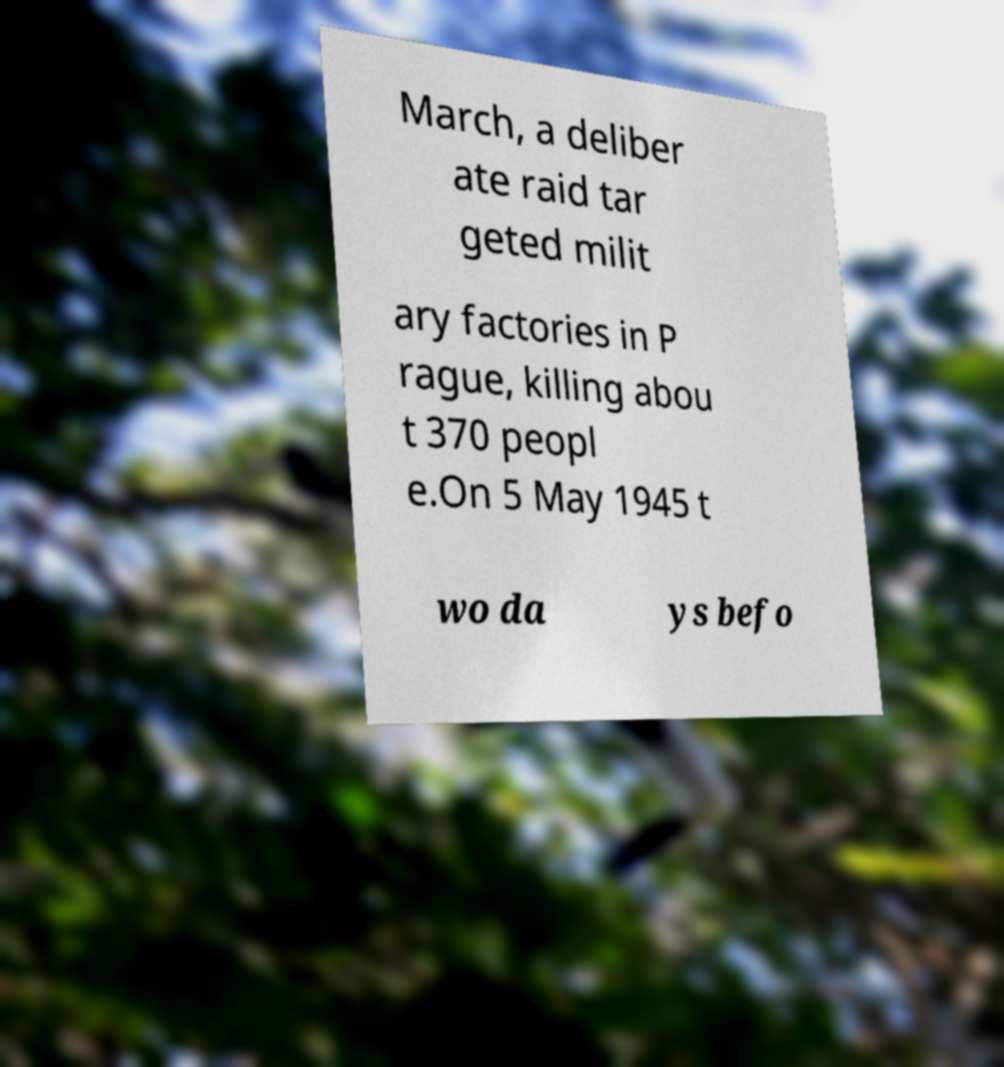Please identify and transcribe the text found in this image. March, a deliber ate raid tar geted milit ary factories in P rague, killing abou t 370 peopl e.On 5 May 1945 t wo da ys befo 